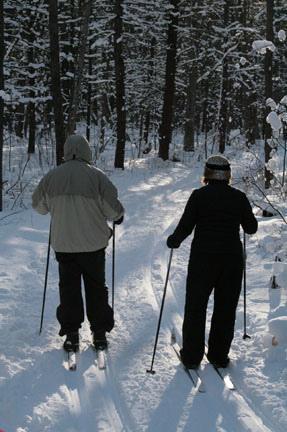How many people are visible?
Give a very brief answer. 2. How many people are there?
Give a very brief answer. 2. How many trees are on between the yellow car and the building?
Give a very brief answer. 0. 